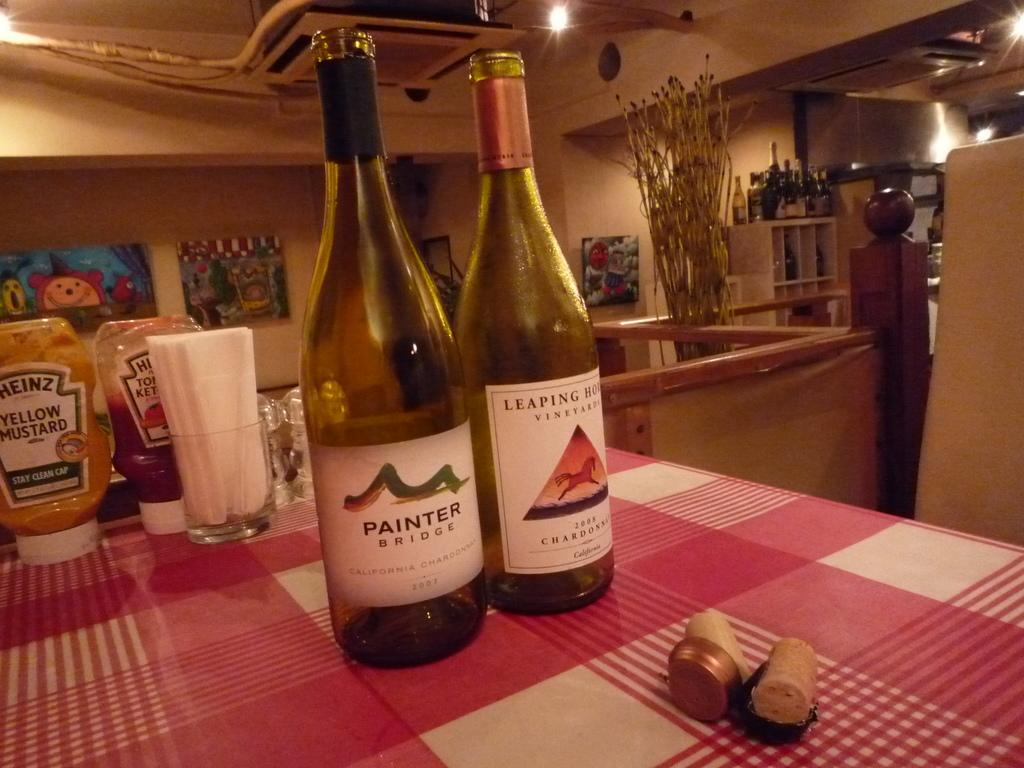<image>
Offer a succinct explanation of the picture presented. two bottles of white wine, opened, one of which is labelled painter. 